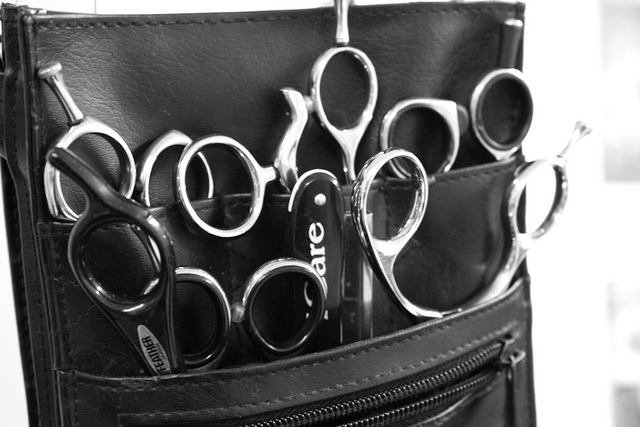Read all the text in this image. are FEATHER 